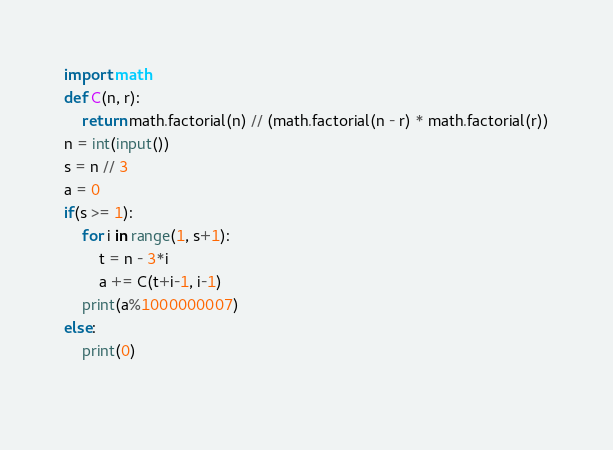<code> <loc_0><loc_0><loc_500><loc_500><_Python_>import math
def C(n, r):
    return math.factorial(n) // (math.factorial(n - r) * math.factorial(r))
n = int(input())
s = n // 3
a = 0
if(s >= 1):
    for i in range(1, s+1):
        t = n - 3*i
        a += C(t+i-1, i-1)
    print(a%1000000007)
else:
    print(0)
    </code> 